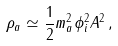<formula> <loc_0><loc_0><loc_500><loc_500>\rho _ { a } \simeq \frac { 1 } { 2 } m _ { a } ^ { 2 } \phi _ { i } ^ { 2 } A ^ { 2 } \, ,</formula> 